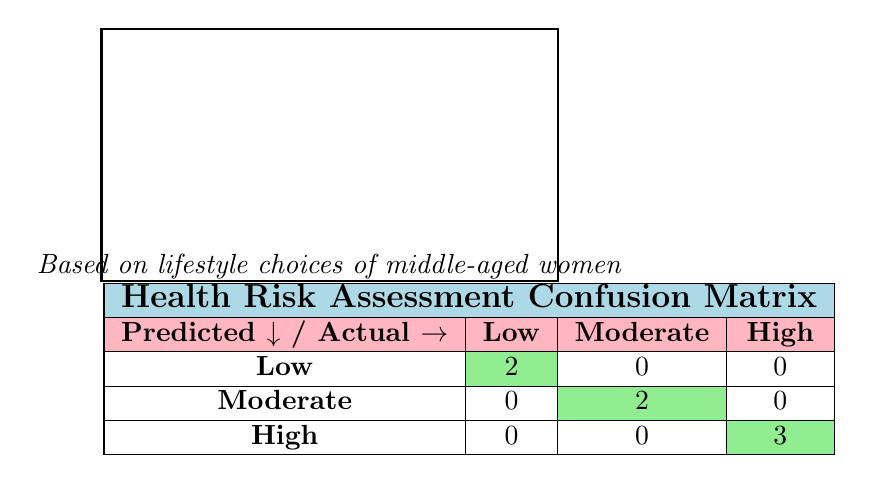What is the count of women assessed as having a low health risk? There are two entries in the table where the actual health risk is categorized as low, corresponding to Jane Smith and Linda Brown.
Answer: 2 How many women were categorized as having a high health risk? The confusion matrix shows that there are three women who were predicted to have a high health risk based on their criteria.
Answer: 3 Are there any women categorized as having a moderate health risk who were predicted correctly? There are two women categorized both as having a moderate health risk and predicted to have moderate risk; this indicates accuracy in prediction.
Answer: Yes What percentage of women predicted to have a low health risk were actually low? The total predictions for low are 2. All of them were correct (2 out of 2), meaning 100% were accurately predicted.
Answer: 100% Can you find the difference between the number of women at moderate risk and those at high risk? The number of women predicted as at moderate risk is 2 and at high risk is 3. Thus, the difference is 3 minus 2, which results in 1.
Answer: 1 How many women were predicted to have a risk level of moderate? The matrix shows 2 entries predicted as moderate risk, corresponding to the actual moderate health risk.
Answer: 2 Is it true that all women classified as low risk were predicted correctly? Yes, the table indicates that both low-risk women were categorized as low, confirming a correct prediction without any misclassification.
Answer: True Which risk category has the greatest number of women predicted accurately? The high-risk group has the most accurate predictions, with three entries indicated as correctly predicted in the confusion matrix.
Answer: High What is the total number of women assessed in the table? The total number of women assessed can be counted from the data entries; there are 7 entries total, which accounts for all individuals assessed.
Answer: 7 